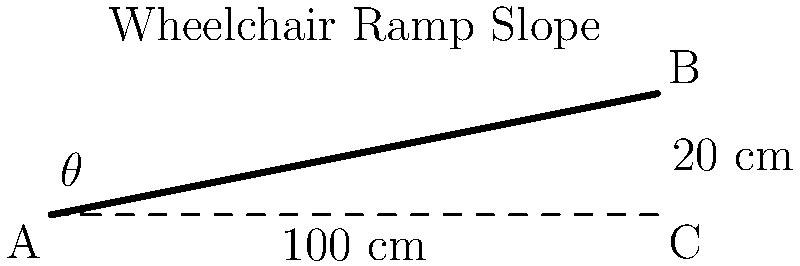As a retired stand-up comedian with a back injury, you're consulting on theater accessibility. A new comedy club wants to install a wheelchair ramp with a horizontal length of 100 cm and a vertical rise of 20 cm. What is the slope of this ramp in percent, and does it meet the ADA (Americans with Disabilities Act) requirement for maximum slope? Let's approach this step-by-step:

1) The slope of a ramp is typically expressed as a ratio of rise to run, or as a percentage.

2) In this case:
   Rise = 20 cm
   Run = 100 cm

3) To calculate the slope as a percentage:
   Slope (%) = (Rise / Run) × 100
   Slope (%) = (20 cm / 100 cm) × 100 = 20%

4) The ADA requirement for maximum slope of a wheelchair ramp is 1:12, which is equivalent to:
   (1 / 12) × 100 = 8.33%

5) Comparing our result to the ADA requirement:
   20% > 8.33%

6) Therefore, this ramp is steeper than the ADA allows.

7) To meet ADA requirements, the ramp would need to be longer. The minimum length for a 20 cm rise would be:
   Length = Rise / (ADA max slope)
   Length = 20 cm / 0.0833 = 240 cm

8) This means the ramp needs to be at least 240 cm long to meet ADA requirements for a 20 cm rise.
Answer: 20%; does not meet ADA requirement (max 8.33%) 